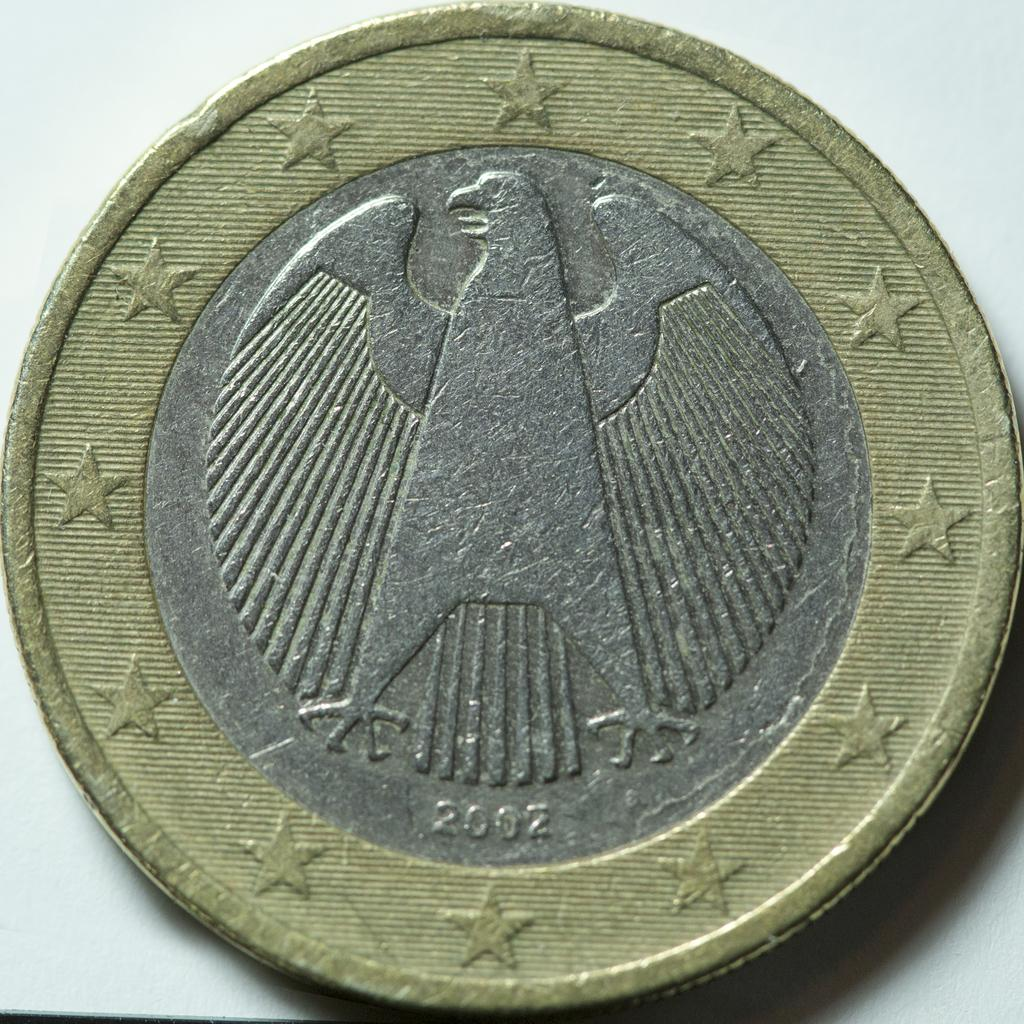What is the main subject of the image? The main subject of the image is a coin. What materials is the coin made of? The coin is made of silver and gold. What is depicted on the coin? There is a picture of an animal on the coin. What else can be seen in the image besides the coin? Stars are visible in the image. What is the color of the surface the coin and stars are on? The surface is white. How does the coin express pain in the image? The coin does not express pain in the image, as it is an inanimate object and cannot feel or express emotions. 